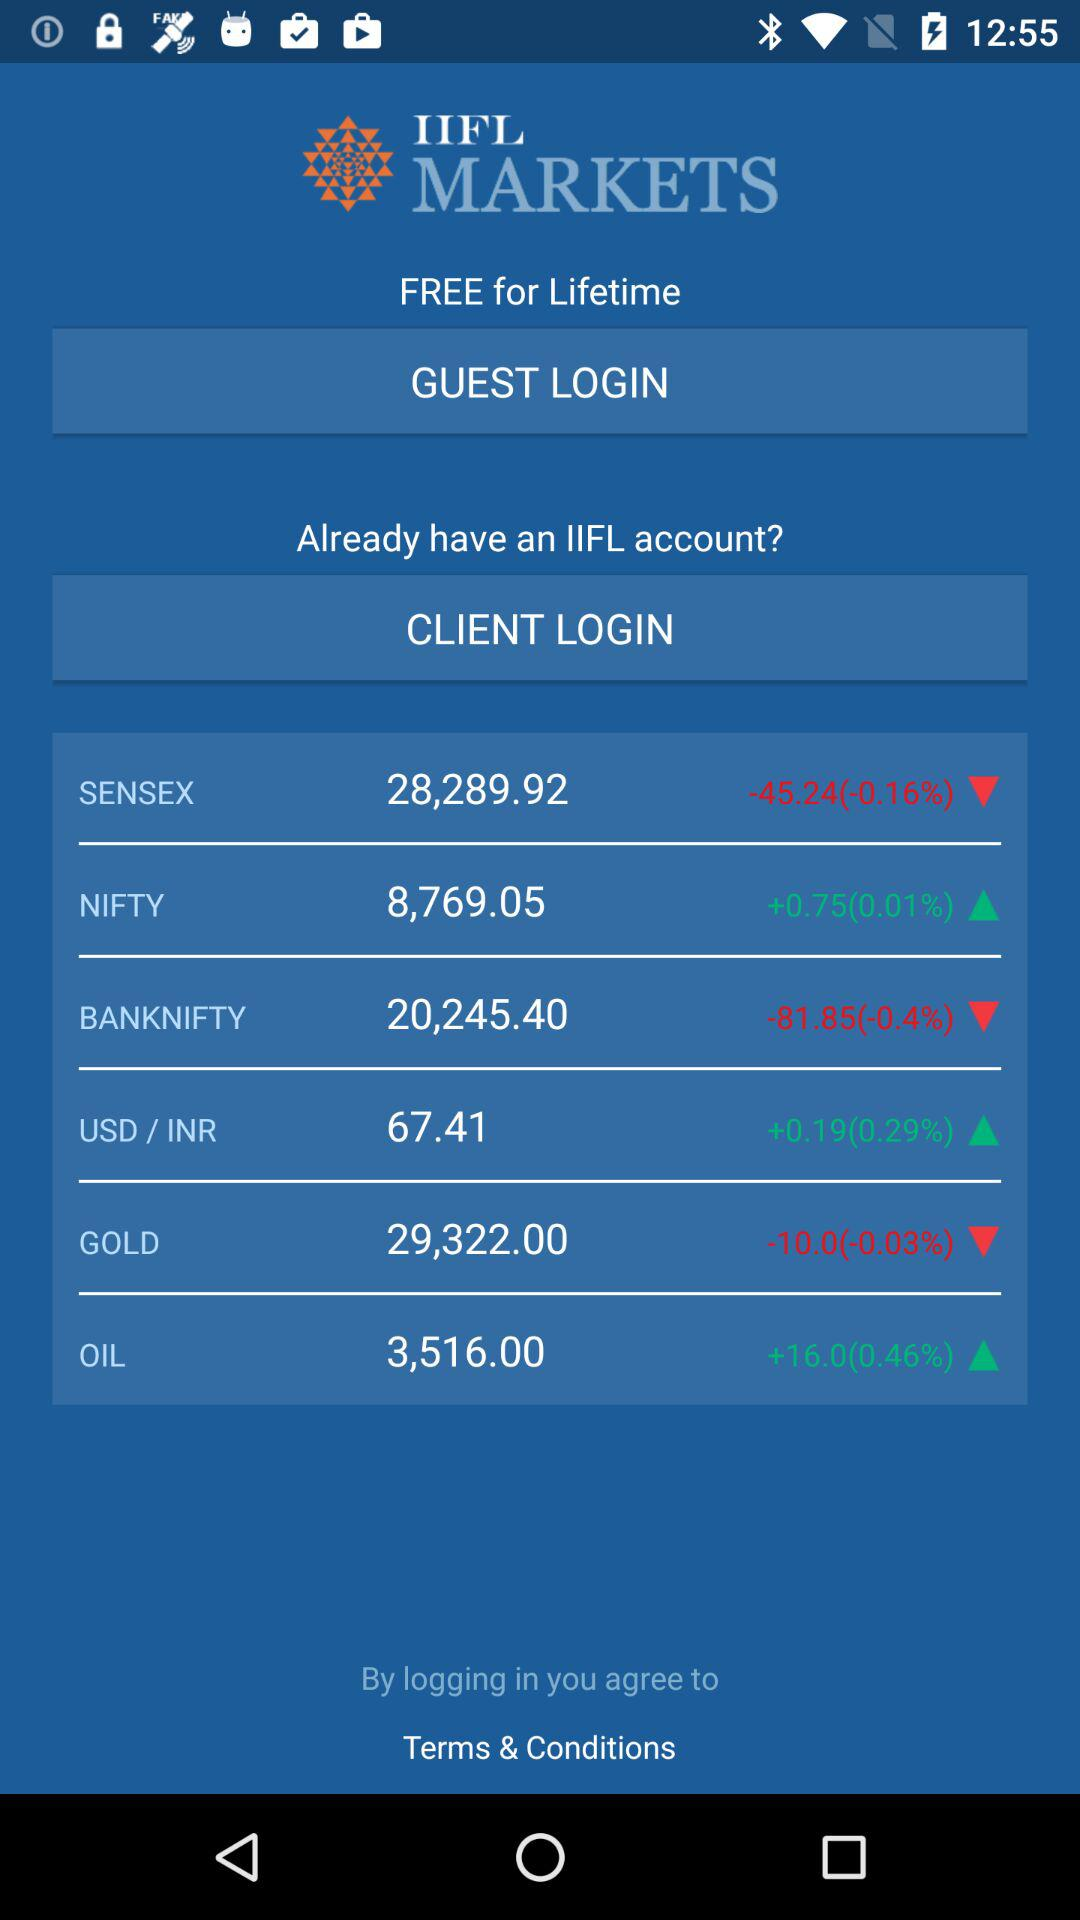What is the percentage increase in "OIL"? There is a 0.46% increase in "OIL". 